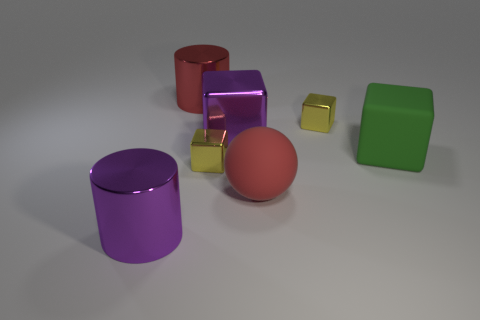Is the shape of the yellow object that is on the left side of the purple block the same as the large green object that is behind the large matte sphere?
Provide a short and direct response. Yes. How many other things are there of the same material as the big red ball?
Provide a succinct answer. 1. What is the shape of the green object that is the same material as the big ball?
Provide a succinct answer. Cube. How big is the purple thing that is in front of the small yellow object that is left of the red matte ball?
Your response must be concise. Large. There is a object that is the same color as the rubber sphere; what shape is it?
Your answer should be very brief. Cylinder. What number of balls are either small yellow objects or big red objects?
Your answer should be compact. 1. Is the size of the green thing the same as the thing in front of the large ball?
Provide a short and direct response. Yes. Is the number of red objects in front of the green thing greater than the number of large yellow metallic blocks?
Ensure brevity in your answer.  Yes. Are there any shiny cylinders that have the same color as the sphere?
Ensure brevity in your answer.  Yes. How many things are either large metallic cylinders or cylinders that are on the right side of the purple metallic cylinder?
Your response must be concise. 2. 